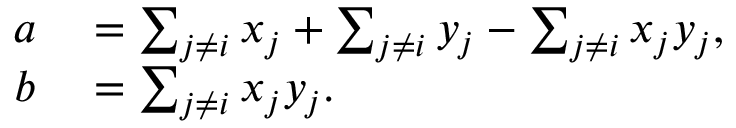<formula> <loc_0><loc_0><loc_500><loc_500>\begin{array} { r l } { a } & = \sum _ { j \neq i } x _ { j } + \sum _ { j \neq i } y _ { j } - \sum _ { j \neq i } x _ { j } y _ { j } , } \\ { b } & = \sum _ { j \neq i } x _ { j } y _ { j } . } \end{array}</formula> 